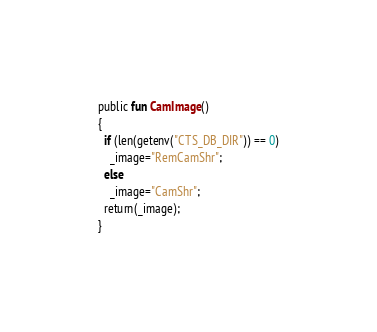Convert code to text. <code><loc_0><loc_0><loc_500><loc_500><_SML_>public fun CamImage()
{
  if (len(getenv("CTS_DB_DIR")) == 0)
    _image="RemCamShr";
  else
    _image="CamShr";
  return(_image);
}
</code> 